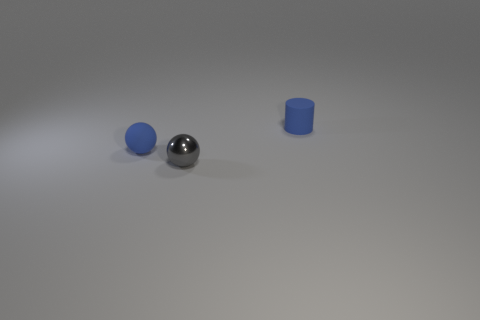Add 1 small red metallic blocks. How many objects exist? 4 Subtract all spheres. How many objects are left? 1 Add 3 metal objects. How many metal objects are left? 4 Add 2 small matte things. How many small matte things exist? 4 Subtract 0 red blocks. How many objects are left? 3 Subtract all red rubber things. Subtract all matte balls. How many objects are left? 2 